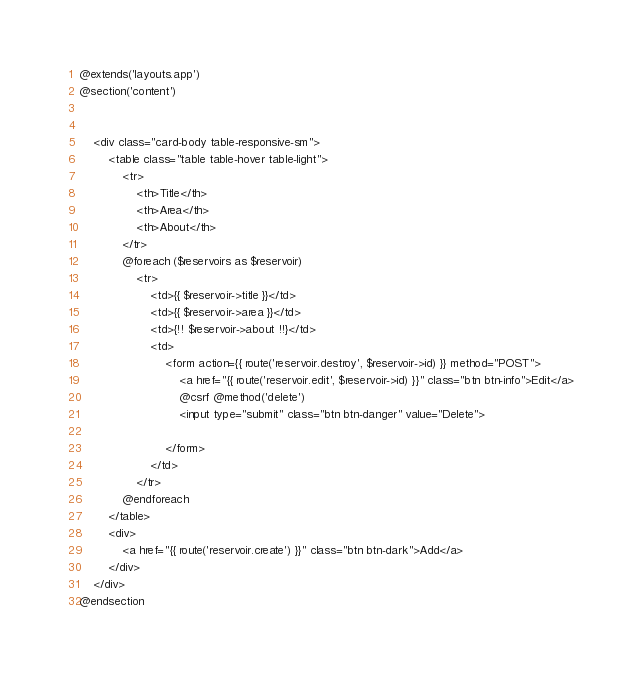<code> <loc_0><loc_0><loc_500><loc_500><_PHP_>@extends('layouts.app')
@section('content')


    <div class="card-body table-responsive-sm">
        <table class="table table-hover table-light">
            <tr>
                <th>Title</th>
                <th>Area</th>
                <th>About</th>
            </tr>
            @foreach ($reservoirs as $reservoir)
                <tr>
                    <td>{{ $reservoir->title }}</td>
                    <td>{{ $reservoir->area }}</td>
                    <td>{!! $reservoir->about !!}</td>
                    <td>
                        <form action={{ route('reservoir.destroy', $reservoir->id) }} method="POST">
                            <a href="{{ route('reservoir.edit', $reservoir->id) }}" class="btn btn-info">Edit</a>
                            @csrf @method('delete')
                            <input type="submit" class="btn btn-danger" value="Delete">

                        </form>
                    </td>
                </tr>
            @endforeach
        </table>
        <div>
            <a href="{{ route('reservoir.create') }}" class="btn btn-dark">Add</a>
        </div>
    </div>
@endsection
</code> 